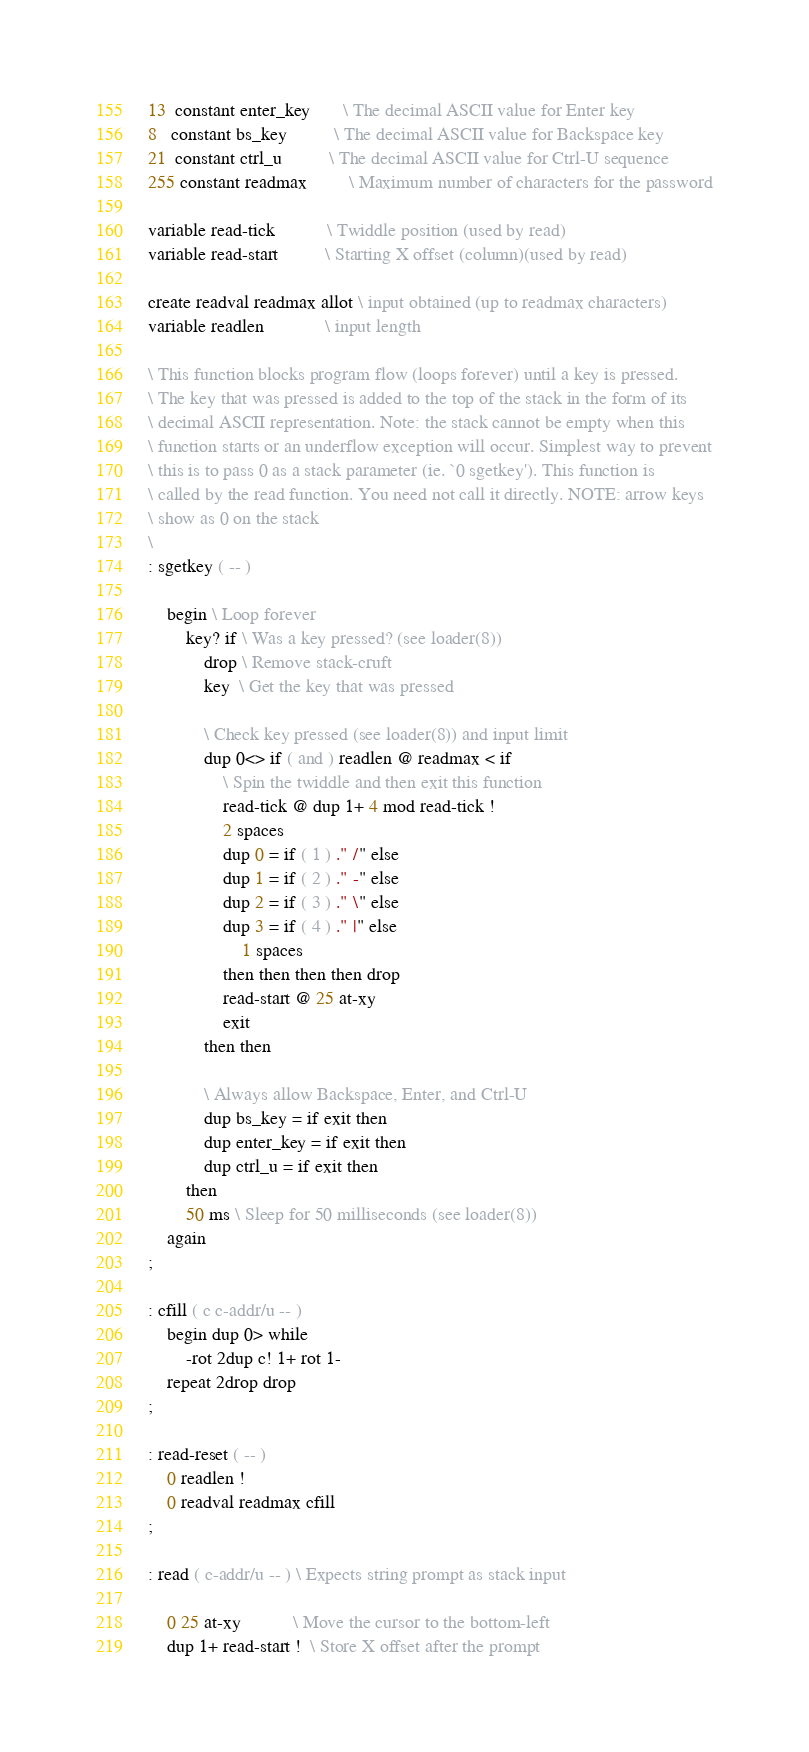<code> <loc_0><loc_0><loc_500><loc_500><_Forth_>13  constant enter_key       \ The decimal ASCII value for Enter key
8   constant bs_key          \ The decimal ASCII value for Backspace key
21  constant ctrl_u          \ The decimal ASCII value for Ctrl-U sequence
255 constant readmax         \ Maximum number of characters for the password

variable read-tick           \ Twiddle position (used by read)
variable read-start          \ Starting X offset (column)(used by read)

create readval readmax allot \ input obtained (up to readmax characters)
variable readlen             \ input length

\ This function blocks program flow (loops forever) until a key is pressed.
\ The key that was pressed is added to the top of the stack in the form of its
\ decimal ASCII representation. Note: the stack cannot be empty when this
\ function starts or an underflow exception will occur. Simplest way to prevent
\ this is to pass 0 as a stack parameter (ie. `0 sgetkey'). This function is
\ called by the read function. You need not call it directly. NOTE: arrow keys
\ show as 0 on the stack
\ 
: sgetkey ( -- )

	begin \ Loop forever
		key? if \ Was a key pressed? (see loader(8))
			drop \ Remove stack-cruft
			key  \ Get the key that was pressed

			\ Check key pressed (see loader(8)) and input limit
			dup 0<> if ( and ) readlen @ readmax < if
				\ Spin the twiddle and then exit this function
				read-tick @ dup 1+ 4 mod read-tick !
				2 spaces
				dup 0 = if ( 1 ) ." /" else
				dup 1 = if ( 2 ) ." -" else
				dup 2 = if ( 3 ) ." \" else
				dup 3 = if ( 4 ) ." |" else
					1 spaces
				then then then then drop
				read-start @ 25 at-xy
				exit
			then then

			\ Always allow Backspace, Enter, and Ctrl-U
			dup bs_key = if exit then
			dup enter_key = if exit then
			dup ctrl_u = if exit then
		then
		50 ms \ Sleep for 50 milliseconds (see loader(8))
	again
;

: cfill ( c c-addr/u -- )
	begin dup 0> while
		-rot 2dup c! 1+ rot 1-
	repeat 2drop drop
;

: read-reset ( -- )
	0 readlen !
	0 readval readmax cfill
;

: read ( c-addr/u -- ) \ Expects string prompt as stack input

	0 25 at-xy           \ Move the cursor to the bottom-left
	dup 1+ read-start !  \ Store X offset after the prompt</code> 